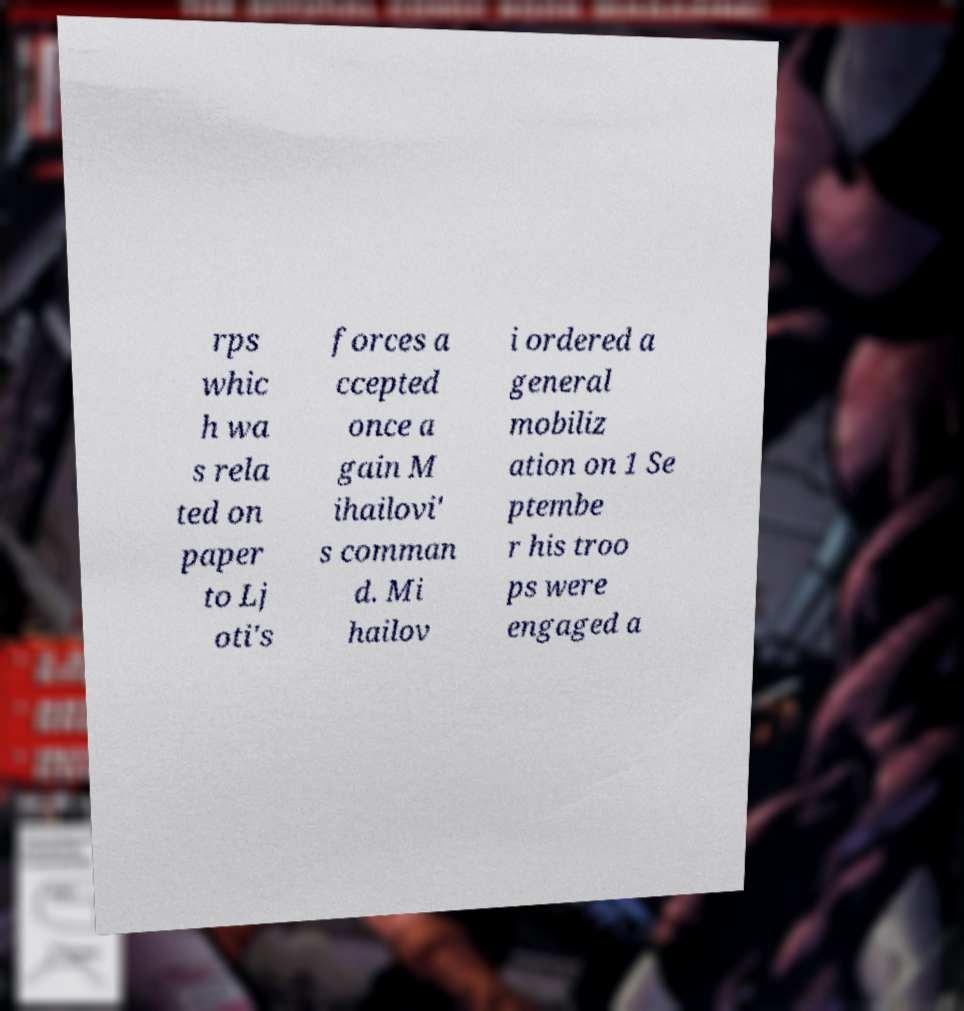Can you read and provide the text displayed in the image?This photo seems to have some interesting text. Can you extract and type it out for me? rps whic h wa s rela ted on paper to Lj oti's forces a ccepted once a gain M ihailovi' s comman d. Mi hailov i ordered a general mobiliz ation on 1 Se ptembe r his troo ps were engaged a 